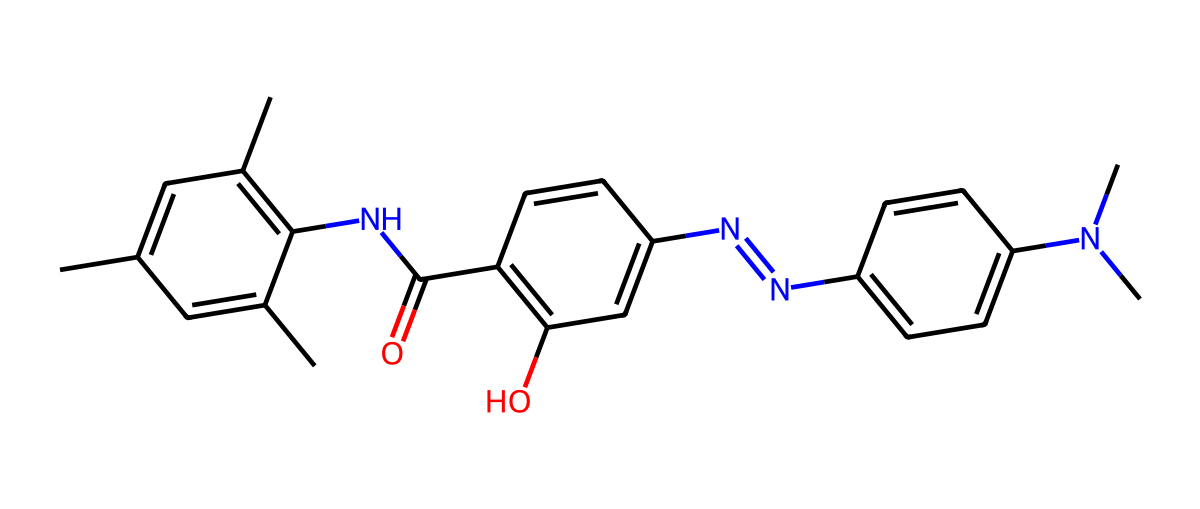What is the total number of carbon atoms in this chemical? Analyzing the SMILES representation, I count each 'C' in the structure. There are additional carbons in the cyclic components and side chains. The total number adds up correctly to 27.
Answer: 27 How many double bonds are present in this structure? By examining the SMILES, I identify each occurrence of '=' which signifies a double bond. In this molecule, there are 6 double bonds present.
Answer: 6 What functional group is indicated by "NC(=O)" in the SMILES? This part of the SMILES represents an amide functional group, as "N" indicates a nitrogen bonded to carbon, specifically one that is double-bonded to oxygen. Thus, it designates the presence of an amide.
Answer: amide What type of chemical reaction can this molecule undergo upon exposure to light? As a photoreactive compound, it can undergo photoisomerization. This refers to a change in the arrangement of atoms and bonds due to light exposure, affecting the thermochromic properties.
Answer: photoisomerization Does this chemical possess any ring structures? Yes, the chemical contains multiple cyclic structures observed through the representation of the carbon atoms forming loops. Specifically, there are 3 distinct rings present in the structure.
Answer: 3 What does the presence of nitrogen atoms imply about the biological activity of this chemical? Nitrogen atoms typically contribute to pharmacological properties, suggesting it may exhibit biological activity, particularly as a potential ligand for binding sites due to its ability to participate in hydrogen bonding and electron sharing.
Answer: biological activity Is this compound likely to change color with temperature changes? Yes, the presence of thermochromic pigments suggests that this compound can change its color with temperature variations, which is an essential feature for its application in temperature-sensitive designs.
Answer: yes 